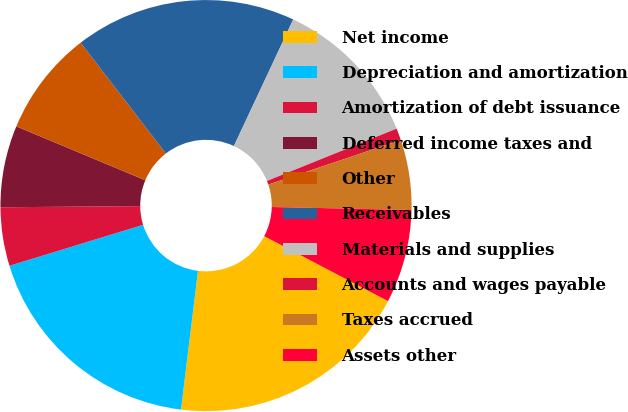Convert chart. <chart><loc_0><loc_0><loc_500><loc_500><pie_chart><fcel>Net income<fcel>Depreciation and amortization<fcel>Amortization of debt issuance<fcel>Deferred income taxes and<fcel>Other<fcel>Receivables<fcel>Materials and supplies<fcel>Accounts and wages payable<fcel>Taxes accrued<fcel>Assets other<nl><fcel>19.25%<fcel>18.33%<fcel>4.6%<fcel>6.43%<fcel>8.26%<fcel>17.42%<fcel>11.92%<fcel>0.94%<fcel>5.51%<fcel>7.35%<nl></chart> 